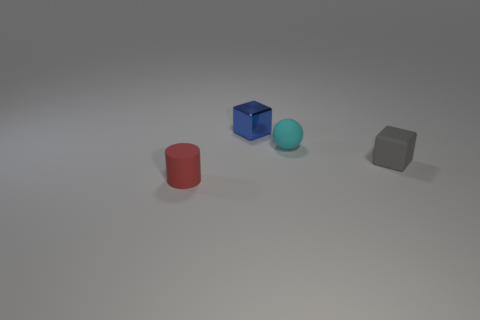Is there any other thing that is made of the same material as the blue cube?
Give a very brief answer. No. How many spheres are large blue metallic objects or small red rubber objects?
Offer a very short reply. 0. Is the number of rubber objects behind the small gray rubber thing the same as the number of small cyan spheres left of the tiny metallic block?
Your response must be concise. No. There is a tiny block on the left side of the gray thing in front of the cyan rubber ball; what number of tiny red things are behind it?
Give a very brief answer. 0. Are there more tiny spheres to the right of the tiny rubber cylinder than tiny yellow matte cylinders?
Ensure brevity in your answer.  Yes. What number of objects are either small objects that are on the left side of the gray matte block or blocks that are in front of the blue metal block?
Offer a terse response. 4. What size is the gray thing that is made of the same material as the small ball?
Make the answer very short. Small. Is the shape of the tiny matte object that is on the right side of the cyan matte thing the same as  the blue shiny thing?
Offer a very short reply. Yes. How many blue objects are either metal objects or small things?
Your answer should be compact. 1. What number of other things are the same shape as the tiny cyan rubber thing?
Ensure brevity in your answer.  0. 